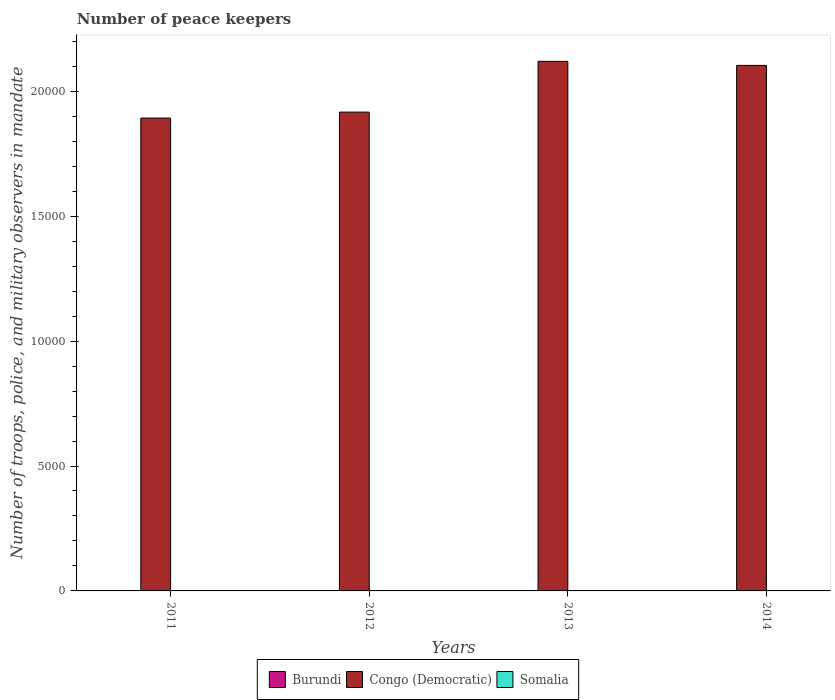How many groups of bars are there?
Your response must be concise. 4. How many bars are there on the 3rd tick from the left?
Make the answer very short. 3. What is the number of peace keepers in in Burundi in 2013?
Offer a very short reply. 2. Across all years, what is the minimum number of peace keepers in in Congo (Democratic)?
Your response must be concise. 1.89e+04. In which year was the number of peace keepers in in Congo (Democratic) minimum?
Your answer should be compact. 2011. What is the difference between the number of peace keepers in in Congo (Democratic) in 2012 and that in 2013?
Keep it short and to the point. -2032. What is the average number of peace keepers in in Congo (Democratic) per year?
Give a very brief answer. 2.01e+04. In the year 2012, what is the difference between the number of peace keepers in in Burundi and number of peace keepers in in Congo (Democratic)?
Keep it short and to the point. -1.92e+04. Is the number of peace keepers in in Congo (Democratic) in 2011 less than that in 2014?
Your answer should be very brief. Yes. Is the difference between the number of peace keepers in in Burundi in 2013 and 2014 greater than the difference between the number of peace keepers in in Congo (Democratic) in 2013 and 2014?
Provide a short and direct response. No. What does the 1st bar from the left in 2012 represents?
Offer a very short reply. Burundi. What does the 2nd bar from the right in 2012 represents?
Give a very brief answer. Congo (Democratic). Is it the case that in every year, the sum of the number of peace keepers in in Congo (Democratic) and number of peace keepers in in Somalia is greater than the number of peace keepers in in Burundi?
Provide a succinct answer. Yes. Are all the bars in the graph horizontal?
Ensure brevity in your answer.  No. What is the difference between two consecutive major ticks on the Y-axis?
Ensure brevity in your answer.  5000. Are the values on the major ticks of Y-axis written in scientific E-notation?
Your response must be concise. No. Where does the legend appear in the graph?
Make the answer very short. Bottom center. How many legend labels are there?
Keep it short and to the point. 3. What is the title of the graph?
Make the answer very short. Number of peace keepers. Does "Swaziland" appear as one of the legend labels in the graph?
Make the answer very short. No. What is the label or title of the Y-axis?
Keep it short and to the point. Number of troops, police, and military observers in mandate. What is the Number of troops, police, and military observers in mandate in Congo (Democratic) in 2011?
Make the answer very short. 1.89e+04. What is the Number of troops, police, and military observers in mandate in Somalia in 2011?
Give a very brief answer. 6. What is the Number of troops, police, and military observers in mandate of Burundi in 2012?
Keep it short and to the point. 2. What is the Number of troops, police, and military observers in mandate of Congo (Democratic) in 2012?
Give a very brief answer. 1.92e+04. What is the Number of troops, police, and military observers in mandate in Burundi in 2013?
Your answer should be very brief. 2. What is the Number of troops, police, and military observers in mandate of Congo (Democratic) in 2013?
Keep it short and to the point. 2.12e+04. What is the Number of troops, police, and military observers in mandate of Burundi in 2014?
Make the answer very short. 2. What is the Number of troops, police, and military observers in mandate in Congo (Democratic) in 2014?
Offer a very short reply. 2.10e+04. What is the Number of troops, police, and military observers in mandate in Somalia in 2014?
Give a very brief answer. 12. Across all years, what is the maximum Number of troops, police, and military observers in mandate in Congo (Democratic)?
Provide a short and direct response. 2.12e+04. Across all years, what is the minimum Number of troops, police, and military observers in mandate in Congo (Democratic)?
Make the answer very short. 1.89e+04. What is the total Number of troops, police, and military observers in mandate in Congo (Democratic) in the graph?
Give a very brief answer. 8.03e+04. What is the total Number of troops, police, and military observers in mandate in Somalia in the graph?
Ensure brevity in your answer.  30. What is the difference between the Number of troops, police, and military observers in mandate of Congo (Democratic) in 2011 and that in 2012?
Make the answer very short. -238. What is the difference between the Number of troops, police, and military observers in mandate in Congo (Democratic) in 2011 and that in 2013?
Ensure brevity in your answer.  -2270. What is the difference between the Number of troops, police, and military observers in mandate in Burundi in 2011 and that in 2014?
Provide a succinct answer. -1. What is the difference between the Number of troops, police, and military observers in mandate in Congo (Democratic) in 2011 and that in 2014?
Provide a succinct answer. -2108. What is the difference between the Number of troops, police, and military observers in mandate of Burundi in 2012 and that in 2013?
Provide a succinct answer. 0. What is the difference between the Number of troops, police, and military observers in mandate of Congo (Democratic) in 2012 and that in 2013?
Give a very brief answer. -2032. What is the difference between the Number of troops, police, and military observers in mandate of Burundi in 2012 and that in 2014?
Give a very brief answer. 0. What is the difference between the Number of troops, police, and military observers in mandate of Congo (Democratic) in 2012 and that in 2014?
Provide a short and direct response. -1870. What is the difference between the Number of troops, police, and military observers in mandate in Somalia in 2012 and that in 2014?
Keep it short and to the point. -9. What is the difference between the Number of troops, police, and military observers in mandate of Congo (Democratic) in 2013 and that in 2014?
Give a very brief answer. 162. What is the difference between the Number of troops, police, and military observers in mandate of Somalia in 2013 and that in 2014?
Your response must be concise. -3. What is the difference between the Number of troops, police, and military observers in mandate of Burundi in 2011 and the Number of troops, police, and military observers in mandate of Congo (Democratic) in 2012?
Give a very brief answer. -1.92e+04. What is the difference between the Number of troops, police, and military observers in mandate in Burundi in 2011 and the Number of troops, police, and military observers in mandate in Somalia in 2012?
Your answer should be very brief. -2. What is the difference between the Number of troops, police, and military observers in mandate in Congo (Democratic) in 2011 and the Number of troops, police, and military observers in mandate in Somalia in 2012?
Your answer should be compact. 1.89e+04. What is the difference between the Number of troops, police, and military observers in mandate of Burundi in 2011 and the Number of troops, police, and military observers in mandate of Congo (Democratic) in 2013?
Offer a terse response. -2.12e+04. What is the difference between the Number of troops, police, and military observers in mandate of Burundi in 2011 and the Number of troops, police, and military observers in mandate of Somalia in 2013?
Offer a terse response. -8. What is the difference between the Number of troops, police, and military observers in mandate of Congo (Democratic) in 2011 and the Number of troops, police, and military observers in mandate of Somalia in 2013?
Provide a short and direct response. 1.89e+04. What is the difference between the Number of troops, police, and military observers in mandate of Burundi in 2011 and the Number of troops, police, and military observers in mandate of Congo (Democratic) in 2014?
Your answer should be compact. -2.10e+04. What is the difference between the Number of troops, police, and military observers in mandate of Congo (Democratic) in 2011 and the Number of troops, police, and military observers in mandate of Somalia in 2014?
Provide a succinct answer. 1.89e+04. What is the difference between the Number of troops, police, and military observers in mandate in Burundi in 2012 and the Number of troops, police, and military observers in mandate in Congo (Democratic) in 2013?
Your answer should be compact. -2.12e+04. What is the difference between the Number of troops, police, and military observers in mandate in Congo (Democratic) in 2012 and the Number of troops, police, and military observers in mandate in Somalia in 2013?
Provide a succinct answer. 1.92e+04. What is the difference between the Number of troops, police, and military observers in mandate in Burundi in 2012 and the Number of troops, police, and military observers in mandate in Congo (Democratic) in 2014?
Provide a short and direct response. -2.10e+04. What is the difference between the Number of troops, police, and military observers in mandate of Congo (Democratic) in 2012 and the Number of troops, police, and military observers in mandate of Somalia in 2014?
Offer a terse response. 1.92e+04. What is the difference between the Number of troops, police, and military observers in mandate in Burundi in 2013 and the Number of troops, police, and military observers in mandate in Congo (Democratic) in 2014?
Keep it short and to the point. -2.10e+04. What is the difference between the Number of troops, police, and military observers in mandate of Congo (Democratic) in 2013 and the Number of troops, police, and military observers in mandate of Somalia in 2014?
Keep it short and to the point. 2.12e+04. What is the average Number of troops, police, and military observers in mandate in Congo (Democratic) per year?
Give a very brief answer. 2.01e+04. What is the average Number of troops, police, and military observers in mandate of Somalia per year?
Your answer should be very brief. 7.5. In the year 2011, what is the difference between the Number of troops, police, and military observers in mandate in Burundi and Number of troops, police, and military observers in mandate in Congo (Democratic)?
Your answer should be very brief. -1.89e+04. In the year 2011, what is the difference between the Number of troops, police, and military observers in mandate in Burundi and Number of troops, police, and military observers in mandate in Somalia?
Ensure brevity in your answer.  -5. In the year 2011, what is the difference between the Number of troops, police, and military observers in mandate in Congo (Democratic) and Number of troops, police, and military observers in mandate in Somalia?
Provide a succinct answer. 1.89e+04. In the year 2012, what is the difference between the Number of troops, police, and military observers in mandate in Burundi and Number of troops, police, and military observers in mandate in Congo (Democratic)?
Your answer should be very brief. -1.92e+04. In the year 2012, what is the difference between the Number of troops, police, and military observers in mandate of Burundi and Number of troops, police, and military observers in mandate of Somalia?
Keep it short and to the point. -1. In the year 2012, what is the difference between the Number of troops, police, and military observers in mandate in Congo (Democratic) and Number of troops, police, and military observers in mandate in Somalia?
Ensure brevity in your answer.  1.92e+04. In the year 2013, what is the difference between the Number of troops, police, and military observers in mandate of Burundi and Number of troops, police, and military observers in mandate of Congo (Democratic)?
Your response must be concise. -2.12e+04. In the year 2013, what is the difference between the Number of troops, police, and military observers in mandate of Burundi and Number of troops, police, and military observers in mandate of Somalia?
Provide a succinct answer. -7. In the year 2013, what is the difference between the Number of troops, police, and military observers in mandate of Congo (Democratic) and Number of troops, police, and military observers in mandate of Somalia?
Make the answer very short. 2.12e+04. In the year 2014, what is the difference between the Number of troops, police, and military observers in mandate in Burundi and Number of troops, police, and military observers in mandate in Congo (Democratic)?
Give a very brief answer. -2.10e+04. In the year 2014, what is the difference between the Number of troops, police, and military observers in mandate in Congo (Democratic) and Number of troops, police, and military observers in mandate in Somalia?
Offer a very short reply. 2.10e+04. What is the ratio of the Number of troops, police, and military observers in mandate of Burundi in 2011 to that in 2012?
Provide a succinct answer. 0.5. What is the ratio of the Number of troops, police, and military observers in mandate of Congo (Democratic) in 2011 to that in 2012?
Provide a succinct answer. 0.99. What is the ratio of the Number of troops, police, and military observers in mandate of Burundi in 2011 to that in 2013?
Give a very brief answer. 0.5. What is the ratio of the Number of troops, police, and military observers in mandate of Congo (Democratic) in 2011 to that in 2013?
Make the answer very short. 0.89. What is the ratio of the Number of troops, police, and military observers in mandate of Somalia in 2011 to that in 2013?
Ensure brevity in your answer.  0.67. What is the ratio of the Number of troops, police, and military observers in mandate in Congo (Democratic) in 2011 to that in 2014?
Ensure brevity in your answer.  0.9. What is the ratio of the Number of troops, police, and military observers in mandate of Congo (Democratic) in 2012 to that in 2013?
Keep it short and to the point. 0.9. What is the ratio of the Number of troops, police, and military observers in mandate in Burundi in 2012 to that in 2014?
Your answer should be very brief. 1. What is the ratio of the Number of troops, police, and military observers in mandate in Congo (Democratic) in 2012 to that in 2014?
Offer a very short reply. 0.91. What is the ratio of the Number of troops, police, and military observers in mandate in Somalia in 2012 to that in 2014?
Ensure brevity in your answer.  0.25. What is the ratio of the Number of troops, police, and military observers in mandate in Burundi in 2013 to that in 2014?
Give a very brief answer. 1. What is the ratio of the Number of troops, police, and military observers in mandate in Congo (Democratic) in 2013 to that in 2014?
Provide a short and direct response. 1.01. What is the difference between the highest and the second highest Number of troops, police, and military observers in mandate of Burundi?
Your answer should be very brief. 0. What is the difference between the highest and the second highest Number of troops, police, and military observers in mandate of Congo (Democratic)?
Make the answer very short. 162. What is the difference between the highest and the lowest Number of troops, police, and military observers in mandate of Congo (Democratic)?
Your answer should be compact. 2270. What is the difference between the highest and the lowest Number of troops, police, and military observers in mandate in Somalia?
Your response must be concise. 9. 